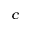<formula> <loc_0><loc_0><loc_500><loc_500>^ { c }</formula> 